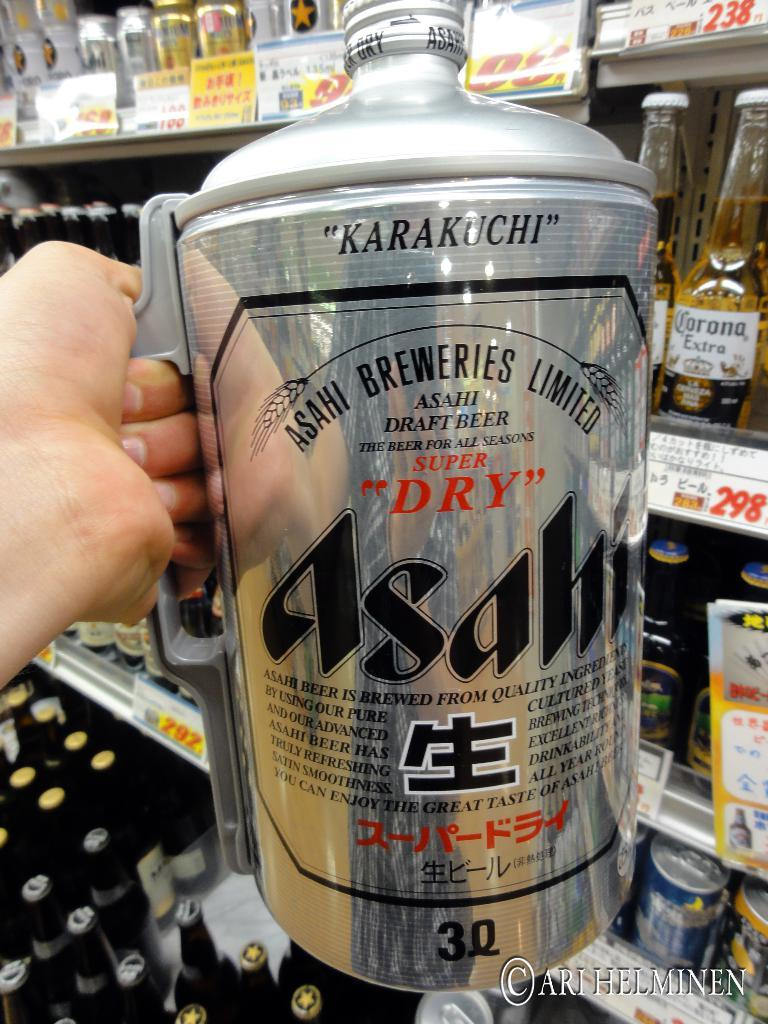<image>
Give a short and clear explanation of the subsequent image. A silver can says Asahi and super dry on the front. 